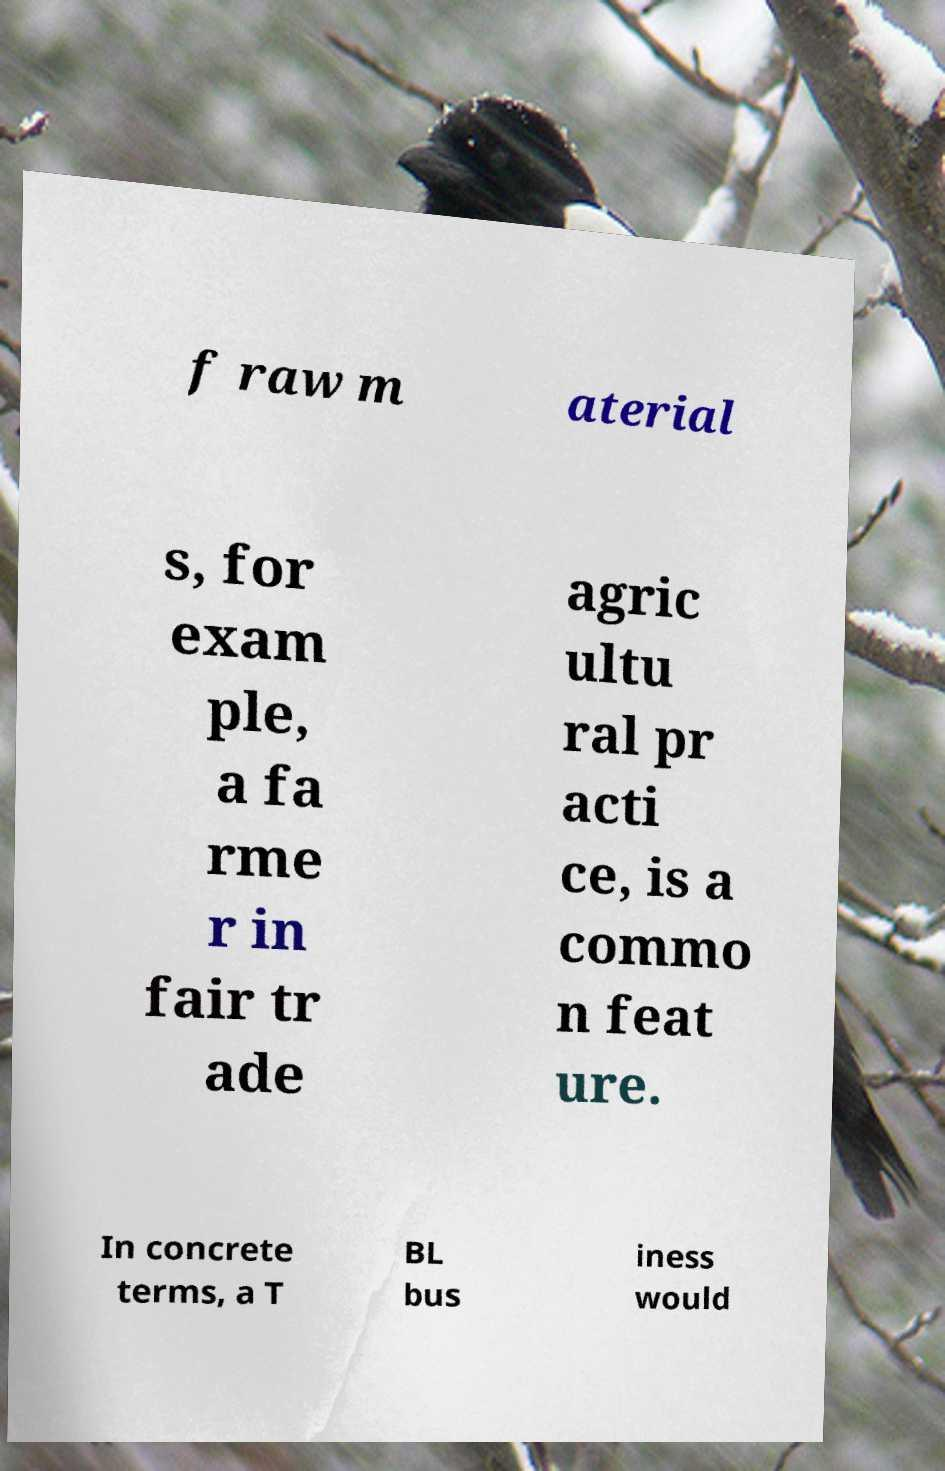Can you accurately transcribe the text from the provided image for me? f raw m aterial s, for exam ple, a fa rme r in fair tr ade agric ultu ral pr acti ce, is a commo n feat ure. In concrete terms, a T BL bus iness would 